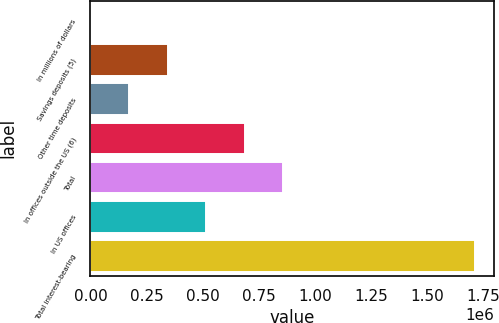Convert chart to OTSL. <chart><loc_0><loc_0><loc_500><loc_500><bar_chart><fcel>In millions of dollars<fcel>Savings deposits (5)<fcel>Other time deposits<fcel>In offices outside the US (6)<fcel>Total<fcel>In US offices<fcel>Total interest-bearing<nl><fcel>2007<fcel>344551<fcel>173279<fcel>687095<fcel>858367<fcel>515823<fcel>1.71473e+06<nl></chart> 